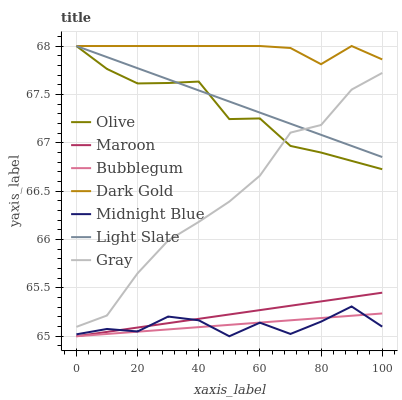Does Midnight Blue have the minimum area under the curve?
Answer yes or no. Yes. Does Dark Gold have the maximum area under the curve?
Answer yes or no. Yes. Does Dark Gold have the minimum area under the curve?
Answer yes or no. No. Does Midnight Blue have the maximum area under the curve?
Answer yes or no. No. Is Light Slate the smoothest?
Answer yes or no. Yes. Is Midnight Blue the roughest?
Answer yes or no. Yes. Is Dark Gold the smoothest?
Answer yes or no. No. Is Dark Gold the roughest?
Answer yes or no. No. Does Midnight Blue have the lowest value?
Answer yes or no. Yes. Does Dark Gold have the lowest value?
Answer yes or no. No. Does Olive have the highest value?
Answer yes or no. Yes. Does Midnight Blue have the highest value?
Answer yes or no. No. Is Midnight Blue less than Gray?
Answer yes or no. Yes. Is Light Slate greater than Bubblegum?
Answer yes or no. Yes. Does Bubblegum intersect Midnight Blue?
Answer yes or no. Yes. Is Bubblegum less than Midnight Blue?
Answer yes or no. No. Is Bubblegum greater than Midnight Blue?
Answer yes or no. No. Does Midnight Blue intersect Gray?
Answer yes or no. No. 